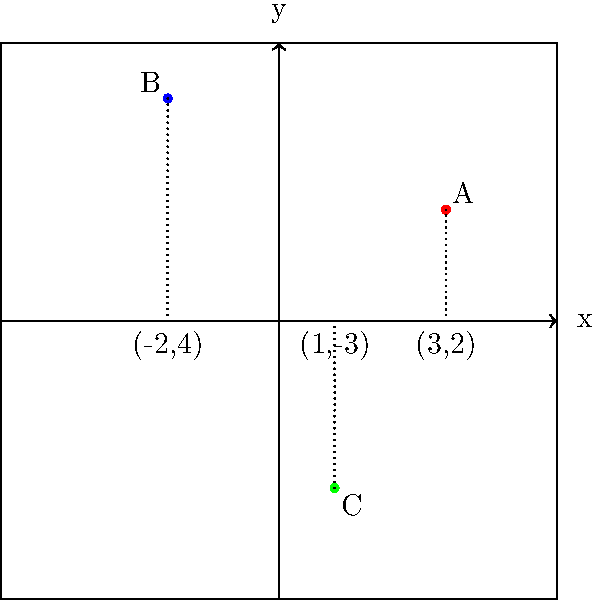As a stage director, you're planning a scene where three actors (A, B, and C) need to be positioned precisely on stage. Using the coordinate system shown, where the origin (0,0) is at the center of the stage, determine the total distance that actor C needs to move to reach the midpoint between actors A and B. Let's approach this step-by-step:

1) First, we need to identify the coordinates of each actor:
   Actor A: (3, 2)
   Actor B: (-2, 4)
   Actor C: (1, -3)

2) To find the midpoint between A and B, we'll use the midpoint formula:
   $(\frac{x_1 + x_2}{2}, \frac{y_1 + y_2}{2})$

3) Midpoint calculation:
   x-coordinate: $\frac{3 + (-2)}{2} = \frac{1}{2} = 0.5$
   y-coordinate: $\frac{2 + 4}{2} = 3$

   So, the midpoint is (0.5, 3)

4) Now, we need to calculate the distance between C's current position (1, -3) and the midpoint (0.5, 3).

5) We can use the distance formula:
   $d = \sqrt{(x_2 - x_1)^2 + (y_2 - y_1)^2}$

6) Plugging in the values:
   $d = \sqrt{(0.5 - 1)^2 + (3 - (-3))^2}$
   $= \sqrt{(-0.5)^2 + 6^2}$
   $= \sqrt{0.25 + 36}$
   $= \sqrt{36.25}$
   $= 6.02$

Therefore, actor C needs to move approximately 6.02 units to reach the midpoint between A and B.
Answer: 6.02 units 